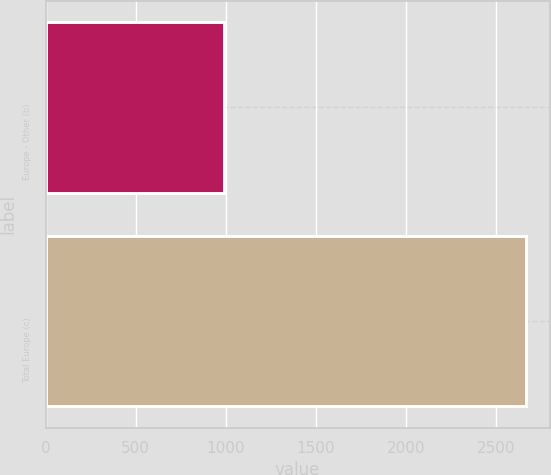Convert chart to OTSL. <chart><loc_0><loc_0><loc_500><loc_500><bar_chart><fcel>Europe - Other (b)<fcel>Total Europe (c)<nl><fcel>992<fcel>2665<nl></chart> 